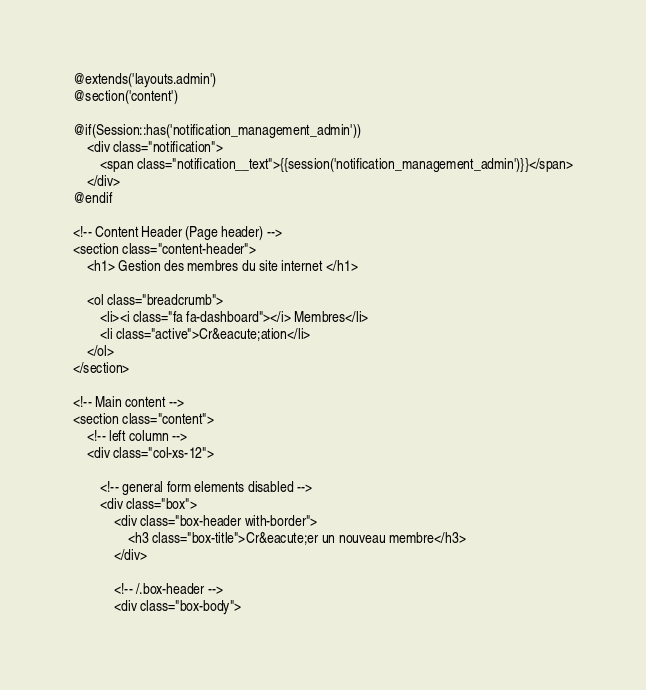Convert code to text. <code><loc_0><loc_0><loc_500><loc_500><_PHP_>@extends('layouts.admin')
@section('content')

@if(Session::has('notification_management_admin'))
    <div class="notification">
        <span class="notification__text">{{session('notification_management_admin')}}</span>
    </div>
@endif

<!-- Content Header (Page header) -->
<section class="content-header">
    <h1> Gestion des membres du site internet </h1>

    <ol class="breadcrumb">
        <li><i class="fa fa-dashboard"></i> Membres</li>
        <li class="active">Cr&eacute;ation</li>
    </ol>
</section>

<!-- Main content -->
<section class="content">
    <!-- left column -->
    <div class="col-xs-12">

        <!-- general form elements disabled -->
        <div class="box">
            <div class="box-header with-border">
                <h3 class="box-title">Cr&eacute;er un nouveau membre</h3>
            </div>

            <!-- /.box-header -->
            <div class="box-body"></code> 